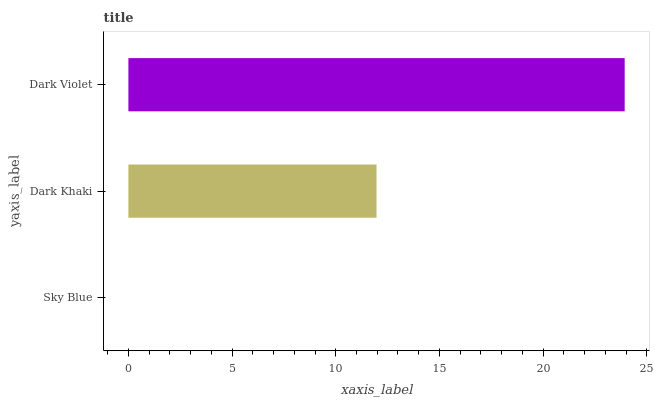Is Sky Blue the minimum?
Answer yes or no. Yes. Is Dark Violet the maximum?
Answer yes or no. Yes. Is Dark Khaki the minimum?
Answer yes or no. No. Is Dark Khaki the maximum?
Answer yes or no. No. Is Dark Khaki greater than Sky Blue?
Answer yes or no. Yes. Is Sky Blue less than Dark Khaki?
Answer yes or no. Yes. Is Sky Blue greater than Dark Khaki?
Answer yes or no. No. Is Dark Khaki less than Sky Blue?
Answer yes or no. No. Is Dark Khaki the high median?
Answer yes or no. Yes. Is Dark Khaki the low median?
Answer yes or no. Yes. Is Dark Violet the high median?
Answer yes or no. No. Is Dark Violet the low median?
Answer yes or no. No. 